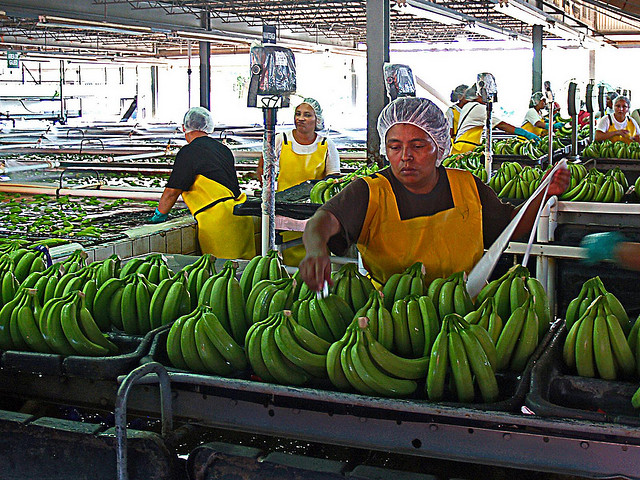Can you describe the process that is taking place in the image? Certainly! The image shows a group of workers at a banana processing facility. The workers are dressed in protective clothing which includes hair caps and aprons. They are involved in sorting and preparing bunches of bananas for packaging and distribution. The bananas go through various stages, such as washing, inspection, and possibly treatment, to ensure that only high-quality fruit is sent to markets. 